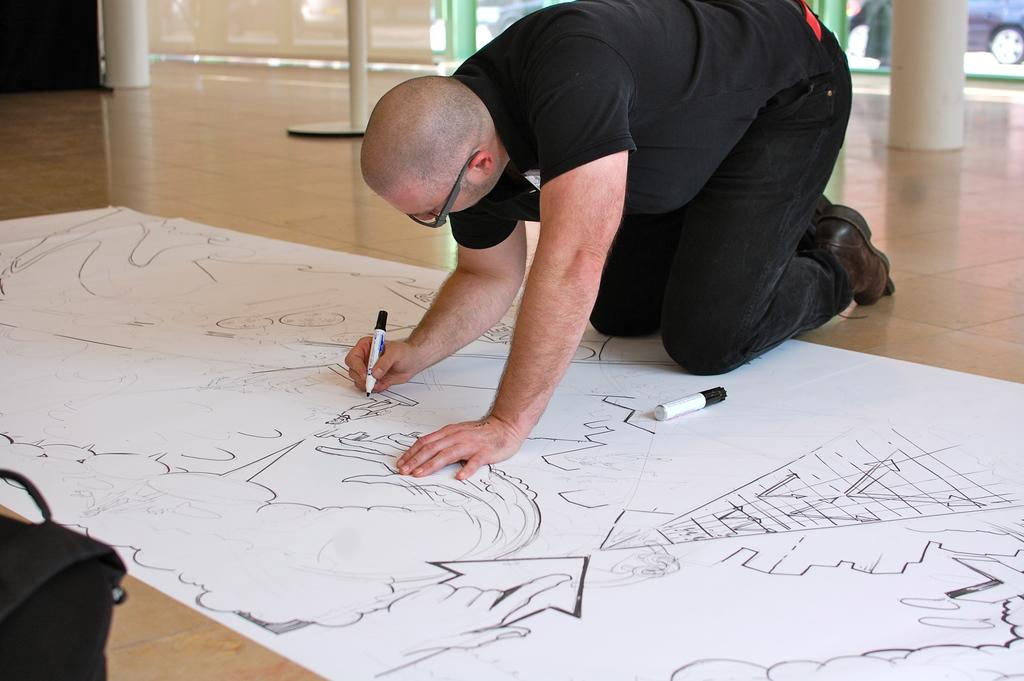What is the appearance of the man in the image? The man in the image is bald-headed. What is the man wearing in the image? The man is wearing a black dress. What is the man doing in the image? The man is laying on the floor and drawing on a canvas with a marker. What can be seen on the left side of the image? There is a bag on the left side of the image. What architectural features are visible in the background of the image? There are pillars in the background of the image. Where does the man store his foldable bed in the image? There is no foldable bed present in the image, and therefore no storage location can be determined. 